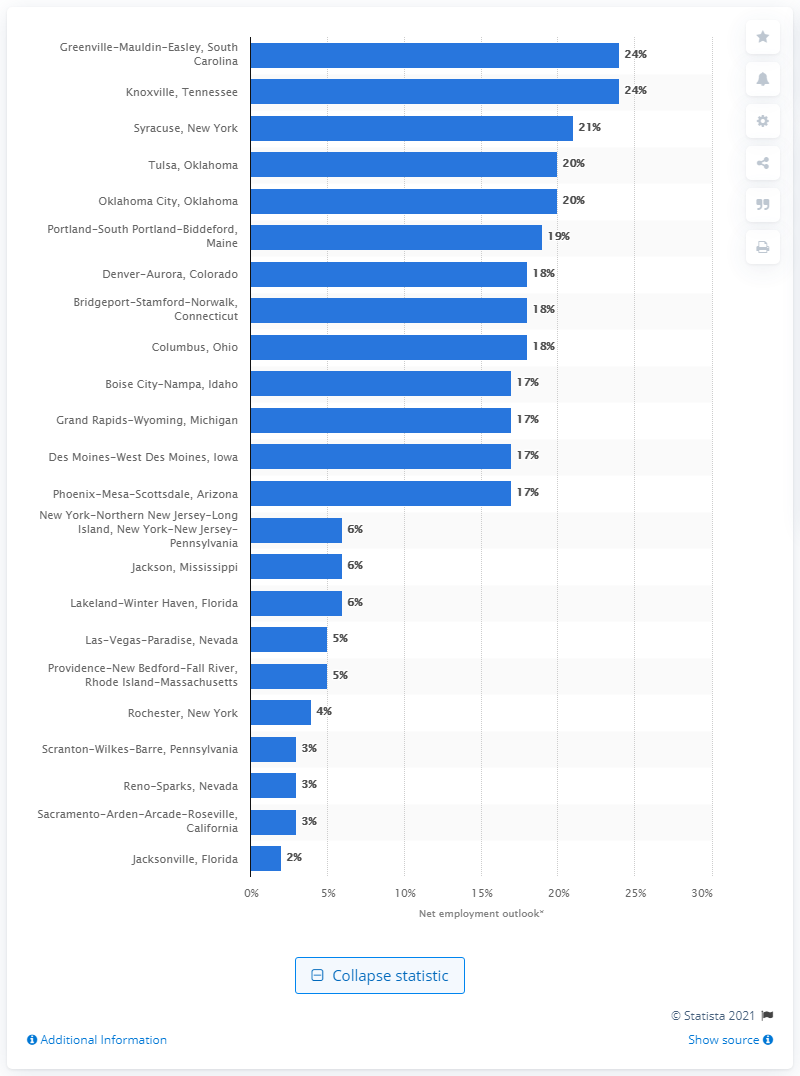Indicate a few pertinent items in this graphic. According to data from the second quarter of 2012, the city of Greenville-Mauldin-Easley in South Carolina was ranked as the worst city for jobs in the United States. 